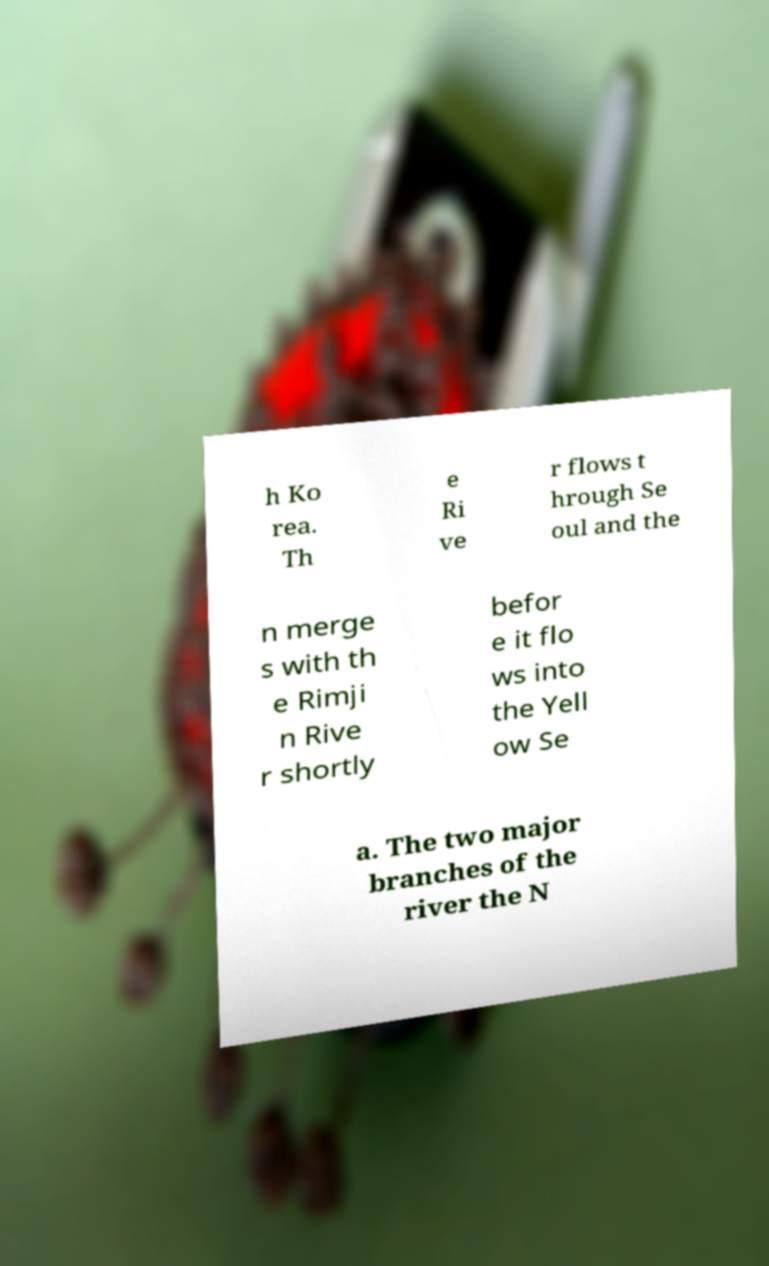Please read and relay the text visible in this image. What does it say? h Ko rea. Th e Ri ve r flows t hrough Se oul and the n merge s with th e Rimji n Rive r shortly befor e it flo ws into the Yell ow Se a. The two major branches of the river the N 